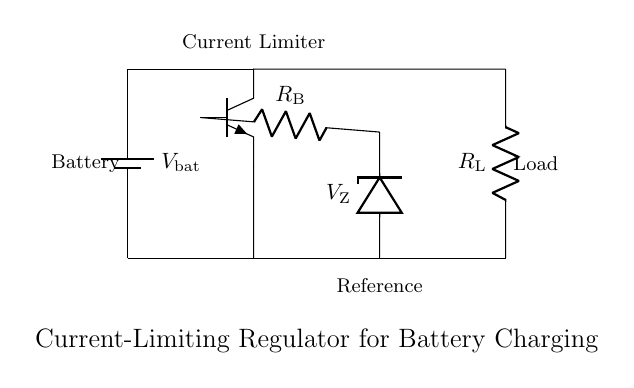what type of transistor is used in the circuit? The circuit diagram shows an NP transistor symbol, indicating that an NPN transistor is being utilized for current regulation.
Answer: NPN what component serves as the reference voltage? The Zener diode in the circuit is marked as the reference component, providing a stable voltage for the current-limiting function.
Answer: Zener diode what is the purpose of the load resistor? The load resistor is connected to the output of the current-limiting regulator, serving to limit the current that can flow to the connected device or load.
Answer: Current limiting how is the battery voltage connected in this circuit? The battery voltage connects directly to the circuit through the battery symbol, providing the necessary voltage for charging to the load through the regulator.
Answer: Directly what happens when the load resistance decreases? When the load resistance decreases, the current through the load increases, which triggers the current-limiting mechanism of the transistor to prevent overcurrent conditions.
Answer: Current limiting kicks in how does the Zener diode affect the transistor operation? The Zener diode allows a specific voltage to be maintained across its terminals, which controls the base of the NPN transistor and keeps the collector-emitter current stable under varying load conditions.
Answer: Maintains base voltage which component is responsible for biasing the transistor in this circuit? The resistor labeled as R_B is responsible for biasing the transistor, allowing it to operate in the active region for regulating the current.
Answer: R_B 